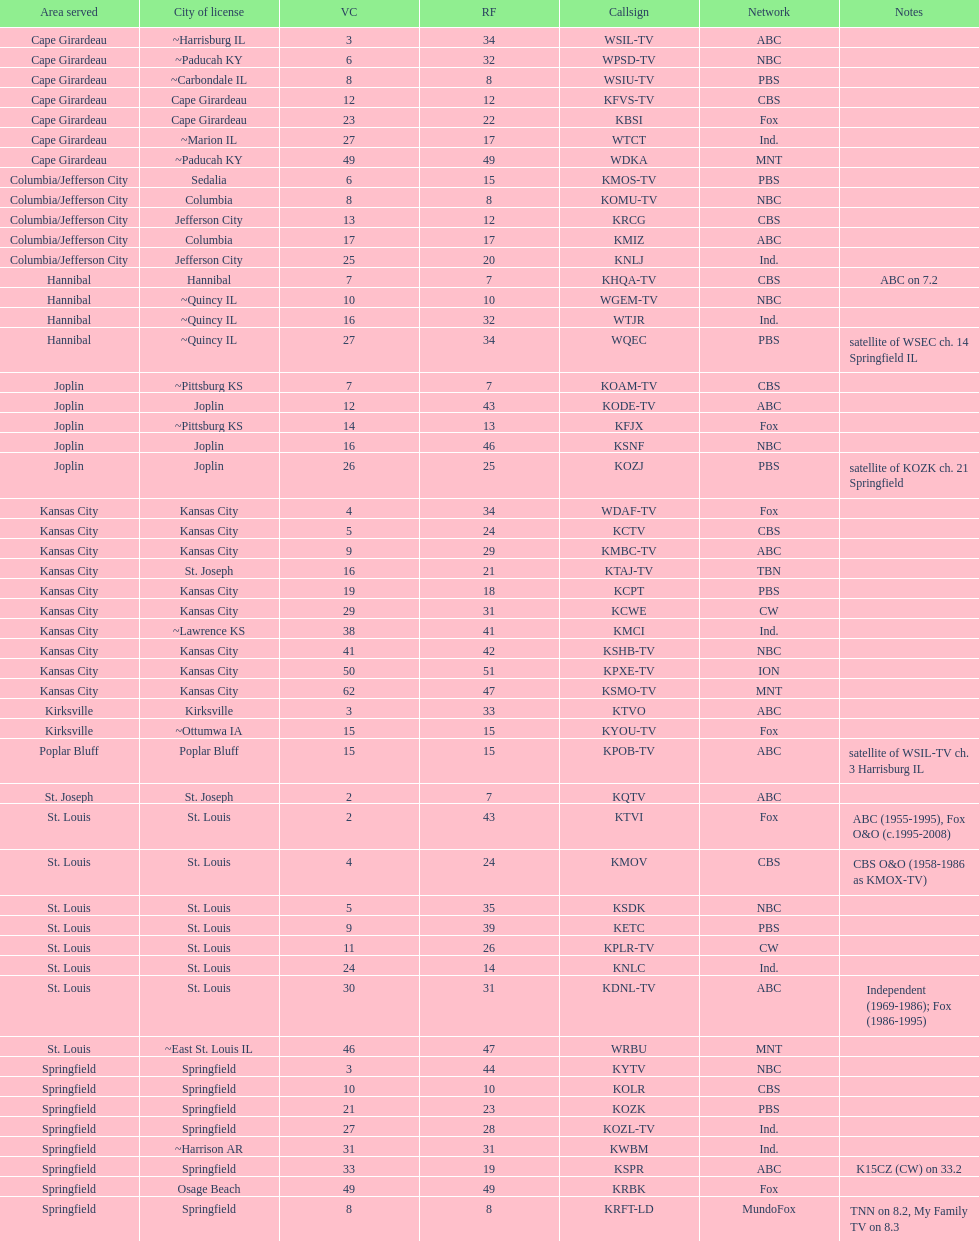What is the count of areas containing 5 or more stations? 6. 